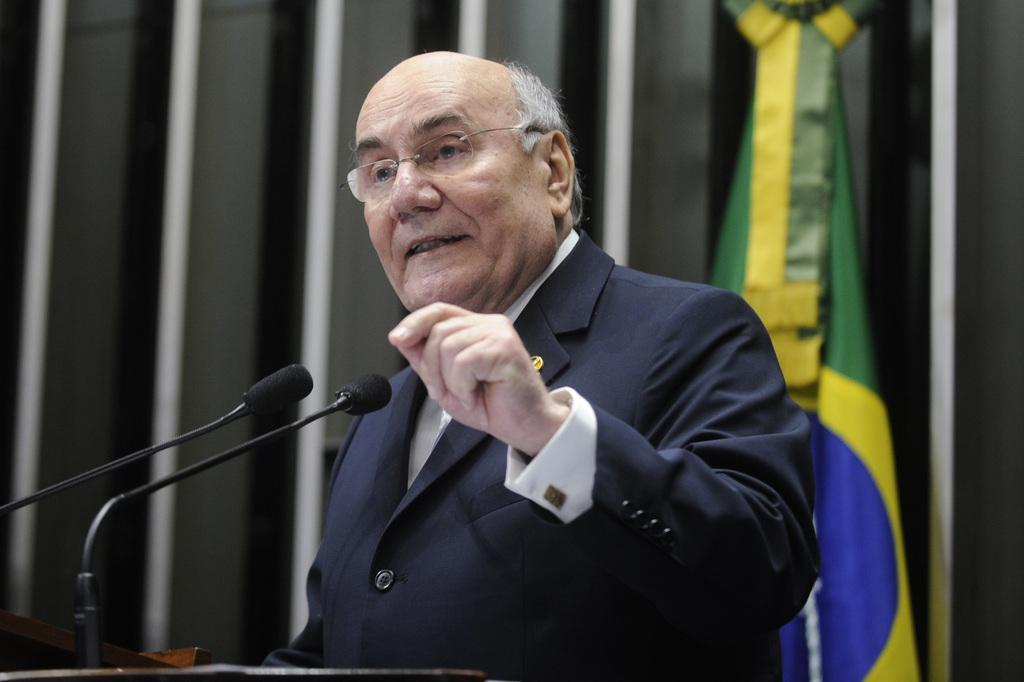Who is the main subject in the picture? There is a man in the picture. What is the man doing in the image? The man is standing in front of a table and speaking. What objects are in front of the man? There are two microphones in front of the man. What can be seen behind the man? There is a flag behind the man. What type of oil can be seen dripping from the window in the image? There is no window or oil present in the image. What activity is the man participating in with the flag in the image? The man is not participating in any activity with the flag in the image; he is simply standing in front of it. 